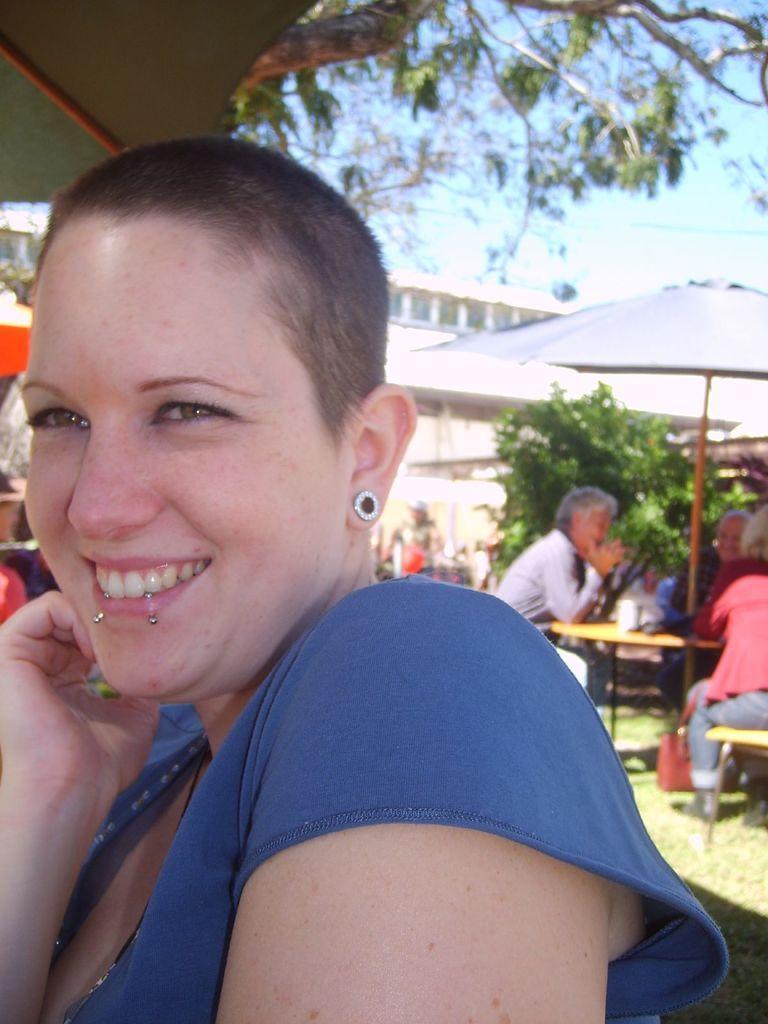Please provide a concise description of this image. In this picture there is a woman who is wearing blue dress and she is smiling. On the right there are three persons were sitting on the chair near to the table. On the table I can see the jar and cup. They are sitting under the umbrella. In the background I can see the building, trees and plants. In the top right corner I can see the sky and clouds. 